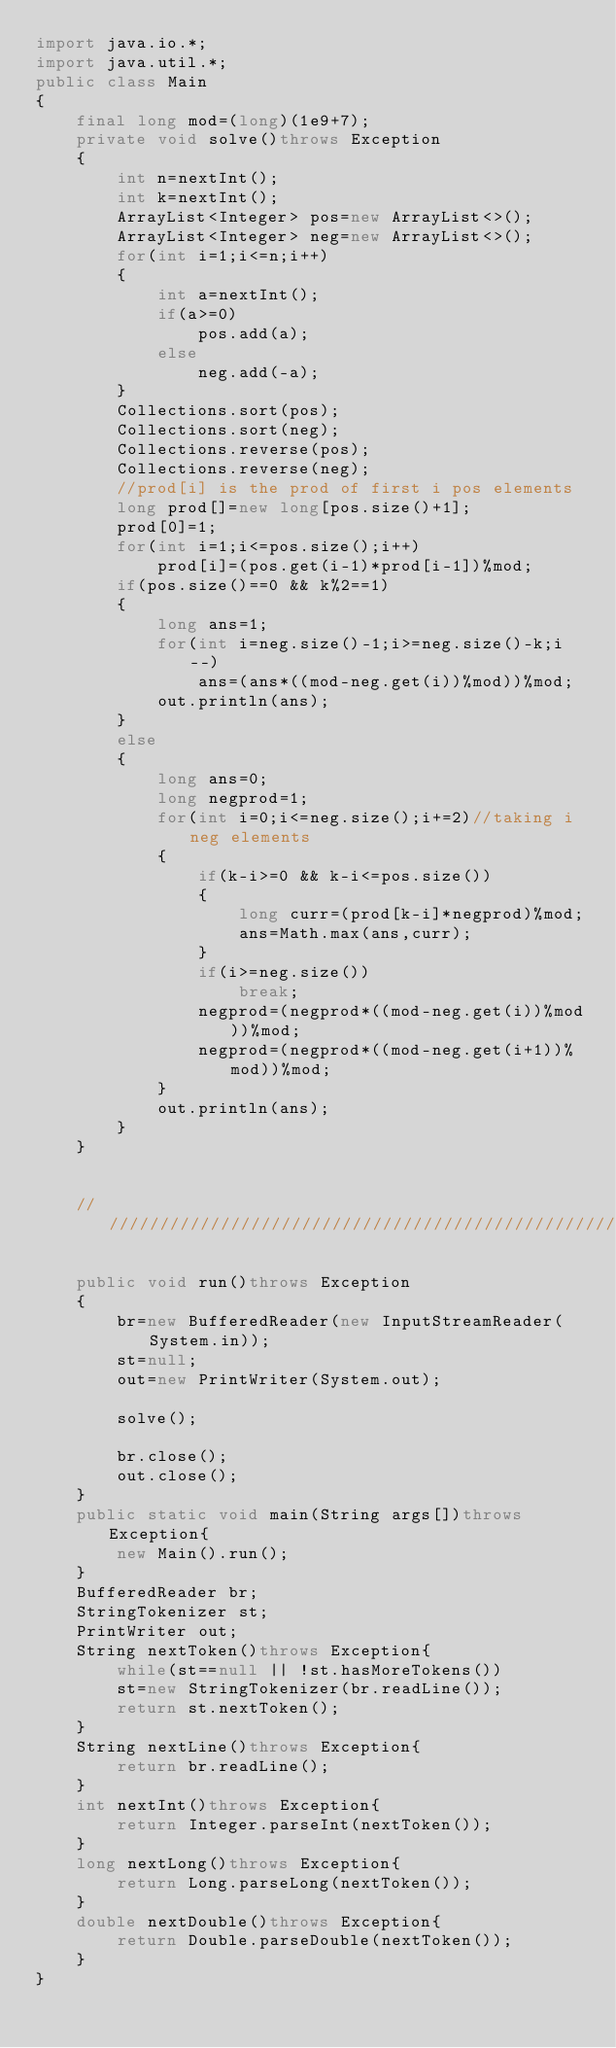<code> <loc_0><loc_0><loc_500><loc_500><_Java_>import java.io.*;
import java.util.*;
public class Main
{
	final long mod=(long)(1e9+7);
	private void solve()throws Exception
	{
		int n=nextInt();
		int k=nextInt();
		ArrayList<Integer> pos=new ArrayList<>();
		ArrayList<Integer> neg=new ArrayList<>();
		for(int i=1;i<=n;i++)
		{
			int a=nextInt();
			if(a>=0)
				pos.add(a);
			else
				neg.add(-a);
		}
		Collections.sort(pos);
		Collections.sort(neg);
		Collections.reverse(pos);
		Collections.reverse(neg);
		//prod[i] is the prod of first i pos elements
		long prod[]=new long[pos.size()+1];
		prod[0]=1;
		for(int i=1;i<=pos.size();i++)
			prod[i]=(pos.get(i-1)*prod[i-1])%mod;
		if(pos.size()==0 && k%2==1)
		{
			long ans=1;
			for(int i=neg.size()-1;i>=neg.size()-k;i--)
				ans=(ans*((mod-neg.get(i))%mod))%mod;
			out.println(ans);
		}
		else
		{
			long ans=0;
			long negprod=1;
			for(int i=0;i<=neg.size();i+=2)//taking i neg elements
			{
				if(k-i>=0 && k-i<=pos.size())
				{
					long curr=(prod[k-i]*negprod)%mod;
					ans=Math.max(ans,curr);
				}
				if(i>=neg.size())
					break;
				negprod=(negprod*((mod-neg.get(i))%mod))%mod;
				negprod=(negprod*((mod-neg.get(i+1))%mod))%mod;
			}
			out.println(ans);
		}
	}

	 
	///////////////////////////////////////////////////////////

	public void run()throws Exception
	{
		br=new BufferedReader(new InputStreamReader(System.in));
		st=null;
		out=new PrintWriter(System.out);

		solve();
		
		br.close();
		out.close();
	}
	public static void main(String args[])throws Exception{
		new Main().run();
	}
	BufferedReader br;
	StringTokenizer st;
	PrintWriter out;
	String nextToken()throws Exception{
		while(st==null || !st.hasMoreTokens())
		st=new StringTokenizer(br.readLine());
		return st.nextToken();
	}
	String nextLine()throws Exception{
		return br.readLine();
	}
	int nextInt()throws Exception{
		return Integer.parseInt(nextToken());
	}
	long nextLong()throws Exception{
		return Long.parseLong(nextToken());
	}
	double nextDouble()throws Exception{
		return Double.parseDouble(nextToken());
	}
}</code> 